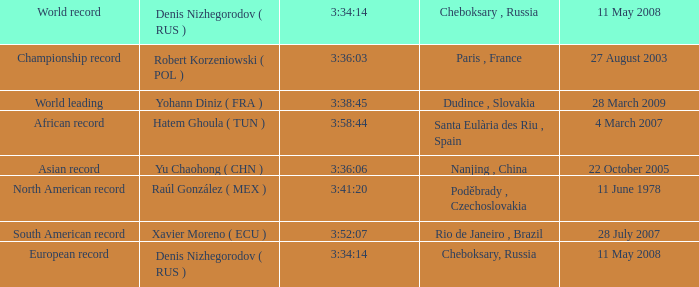In the context where 3:41:20 is the same as 3:34:14, what is the meaning of cheboksary, russia? Poděbrady , Czechoslovakia. 